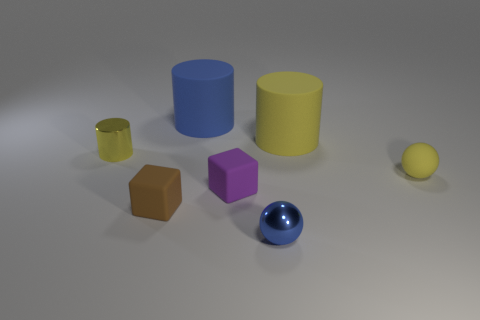What number of tiny metallic things are the same shape as the big blue matte object?
Ensure brevity in your answer.  1. What is the shape of the big blue rubber thing?
Your answer should be very brief. Cylinder. Are there more purple blocks that are to the right of the yellow ball than brown cubes?
Ensure brevity in your answer.  No. What number of things are either small matte things to the left of the tiny purple matte cube or rubber things to the right of the blue metal sphere?
Your answer should be compact. 3. The object that is made of the same material as the tiny blue ball is what size?
Keep it short and to the point. Small. Does the shiny object on the right side of the big blue object have the same shape as the yellow metal object?
Your answer should be very brief. No. There is a rubber cylinder that is the same color as the rubber ball; what size is it?
Your answer should be very brief. Large. How many blue objects are either rubber things or metal balls?
Provide a succinct answer. 2. What number of other objects are there of the same shape as the large yellow matte thing?
Provide a succinct answer. 2. There is a object that is behind the purple thing and in front of the tiny metal cylinder; what is its shape?
Make the answer very short. Sphere. 